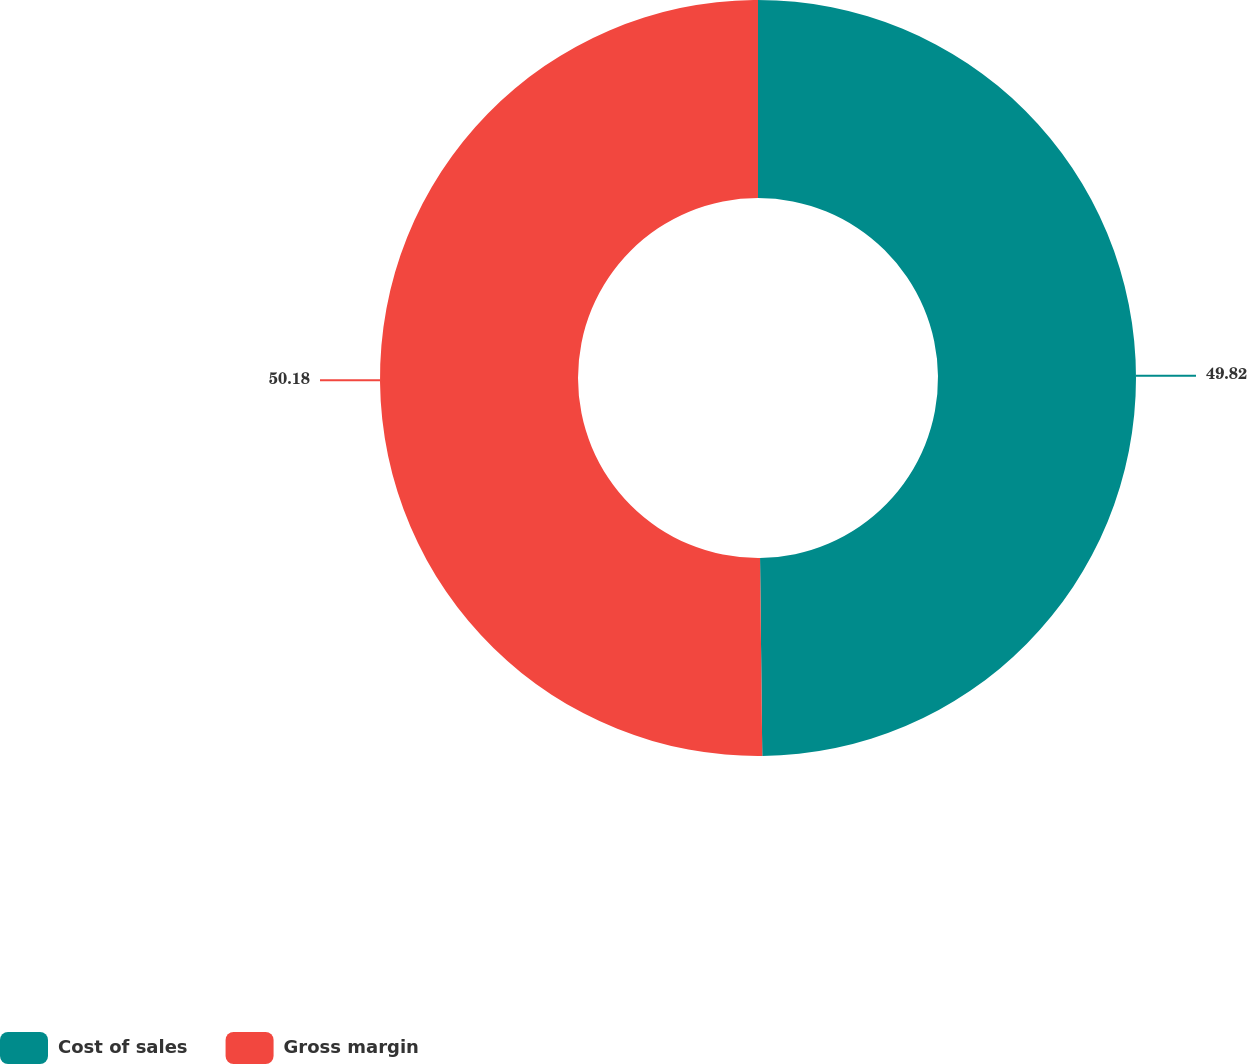Convert chart to OTSL. <chart><loc_0><loc_0><loc_500><loc_500><pie_chart><fcel>Cost of sales<fcel>Gross margin<nl><fcel>49.82%<fcel>50.18%<nl></chart> 